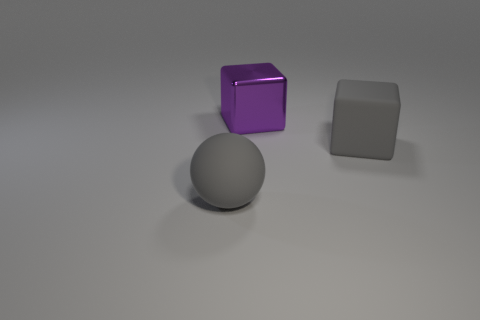Add 2 big metallic cubes. How many objects exist? 5 Subtract all spheres. How many objects are left? 2 Add 3 small yellow metallic cylinders. How many small yellow metallic cylinders exist? 3 Subtract 0 red cylinders. How many objects are left? 3 Subtract all large red rubber cylinders. Subtract all big objects. How many objects are left? 0 Add 3 big purple things. How many big purple things are left? 4 